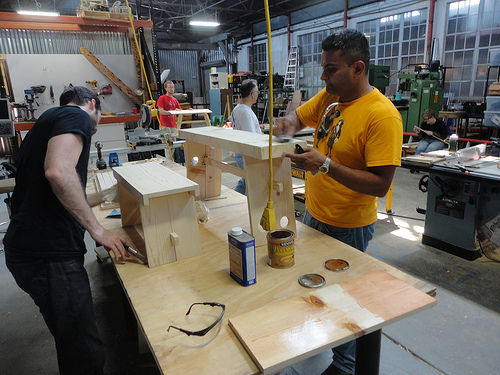<image>
Is the glasses to the left of the board? Yes. From this viewpoint, the glasses is positioned to the left side relative to the board. 